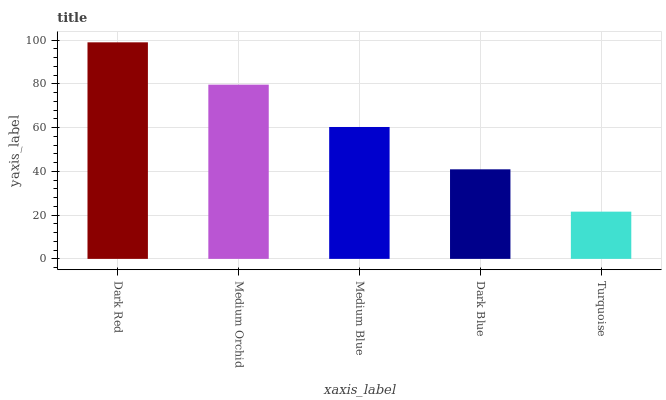Is Medium Orchid the minimum?
Answer yes or no. No. Is Medium Orchid the maximum?
Answer yes or no. No. Is Dark Red greater than Medium Orchid?
Answer yes or no. Yes. Is Medium Orchid less than Dark Red?
Answer yes or no. Yes. Is Medium Orchid greater than Dark Red?
Answer yes or no. No. Is Dark Red less than Medium Orchid?
Answer yes or no. No. Is Medium Blue the high median?
Answer yes or no. Yes. Is Medium Blue the low median?
Answer yes or no. Yes. Is Dark Red the high median?
Answer yes or no. No. Is Dark Red the low median?
Answer yes or no. No. 